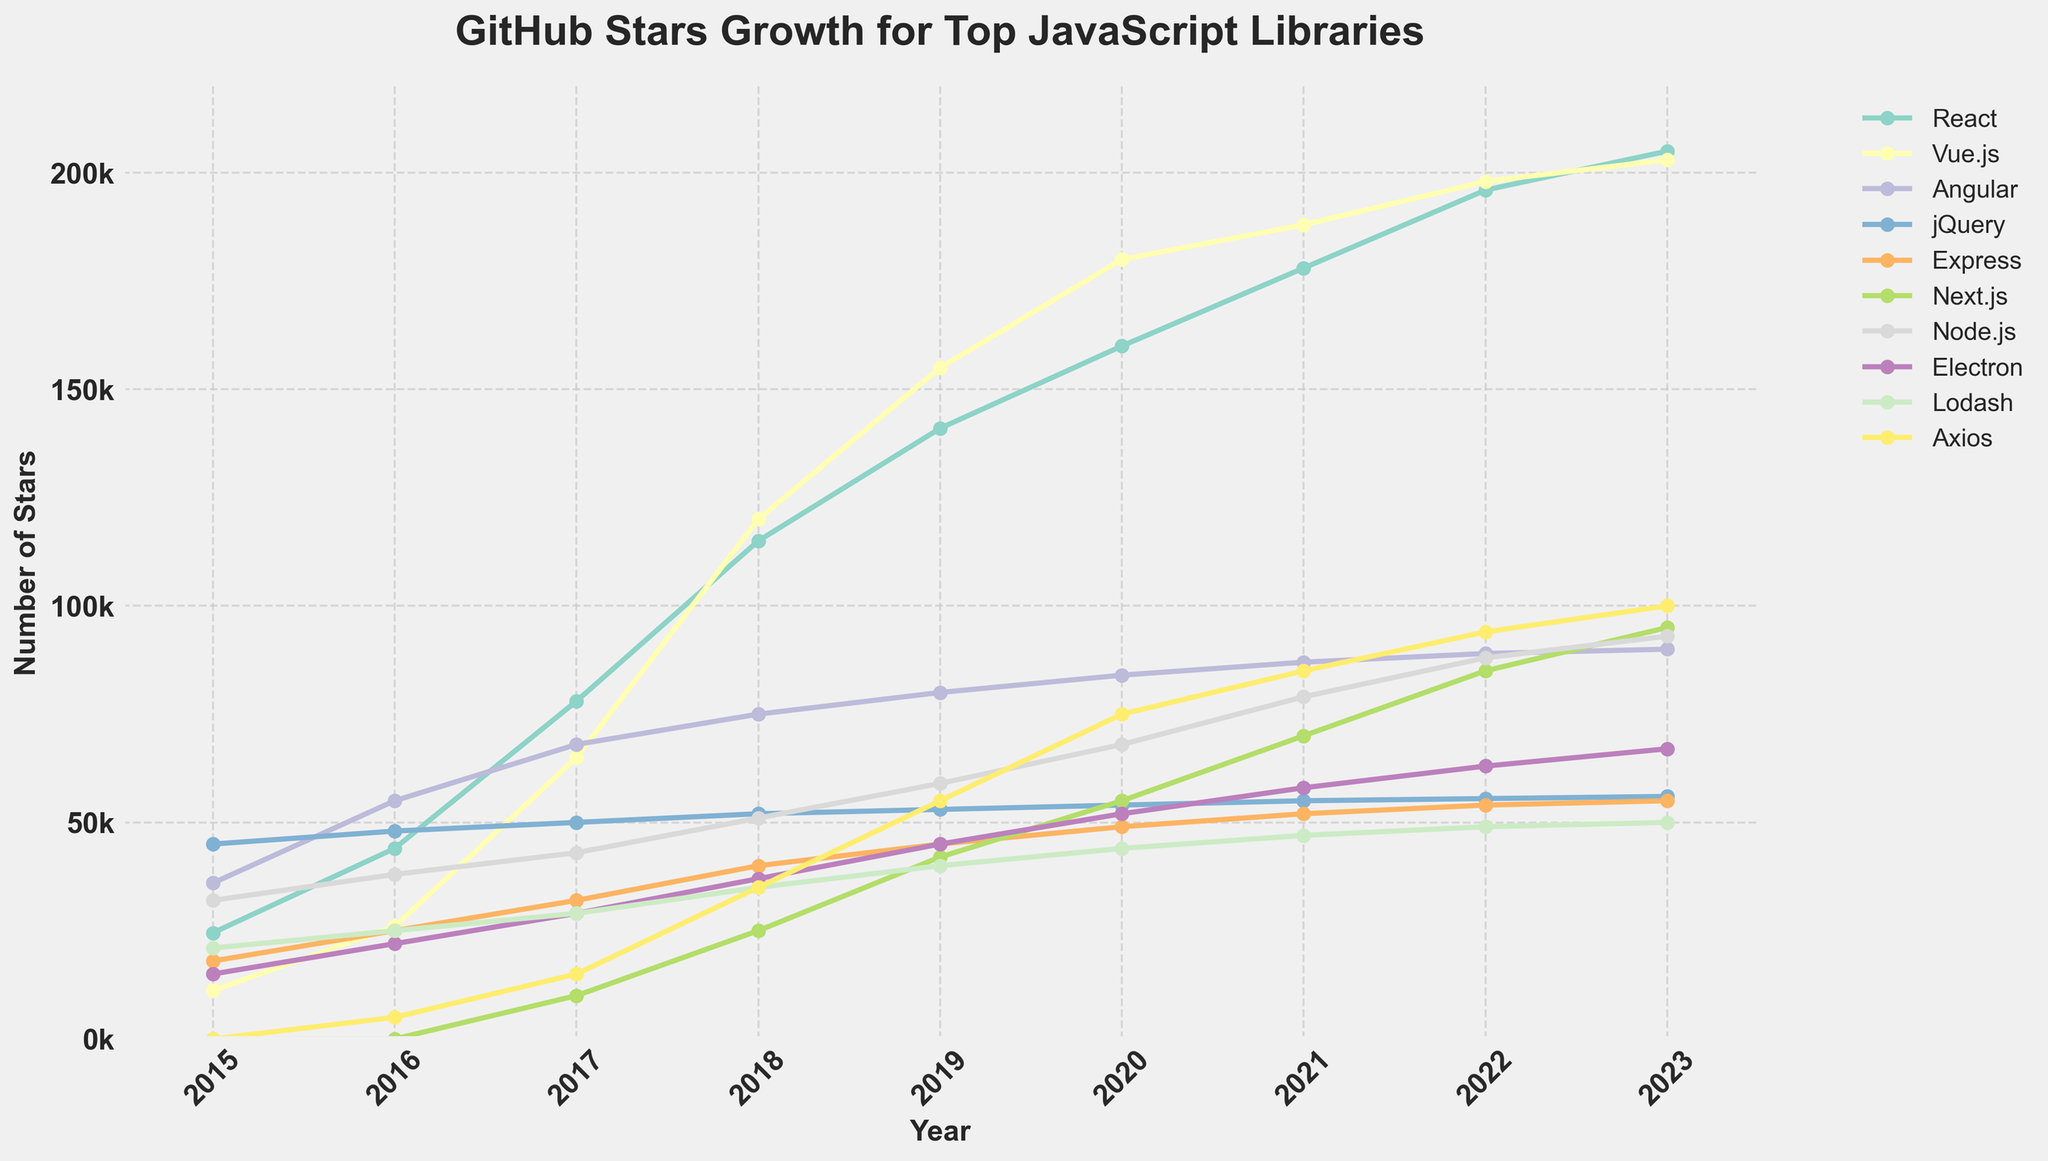Which JavaScript library had the highest star count in 2023? React had the highest star count in 2023. Observe the y-values on the line chart for 2023 and identify the plot with the maximum value, which is React at 205,000 stars.
Answer: React Which year did Vue.js surpass Angular in star count? Vue.js surpassed Angular in 2016. Compare the star counts for both libraries across the years until you find that Vue.js started having a larger star count than Angular from 2016 onwards.
Answer: 2016 Which library shows the most consistent growth year over year? React shows the most consistent growth year over year. By observing the trend lines for each library, React's line steadily climbs upwards without any noticeable drops or flat segments.
Answer: React What's the difference in star count between Vue.js and Angular in 2019? The star count for Vue.js in 2019 is 155,000, and for Angular, it's 80,000. The difference is 155,000 - 80,000 = 75,000.
Answer: 75,000 Which libraries had zero stars in 2015? In 2015, Next.js and Axios had zero stars, which can be seen from the y-values marked as 0 for both these libraries in that year.
Answer: Next.js, Axios What's the average number of stars for jQuery from 2015 to 2023? Sum the star counts for jQuery over the years: 45000 + 48000 + 50000 + 52000 + 53000 + 54000 + 55000 + 55500 + 56000 = 468500. Divide by the number of years (9). The average is 468500 / 9 ≈ 52055.56
Answer: 52055.56 Which library achieved over 100,000 stars the earliest? React achieved over 100,000 stars the earliest in 2017. By examining the trends, React crosses the 100,000 mark in 2017, earlier than any other library.
Answer: React Compare the star counts of Node.js and Lodash in 2023. Which one has more stars, and by how much? Node.js has 93,000 stars, and Lodash has 50,000 stars in 2023. Node.js has more stars by a difference of 93,000 - 50,000 = 43,000.
Answer: Node.js by 43,000 Which two libraries had almost parallel growth from 2020 to 2023? Next.js and Axios had almost parallel growth from 2020 to 2023. By observing their trend lines from 2020 to 2023, both lines run in a similar direction and rate of growth.
Answer: Next.js, Axios 